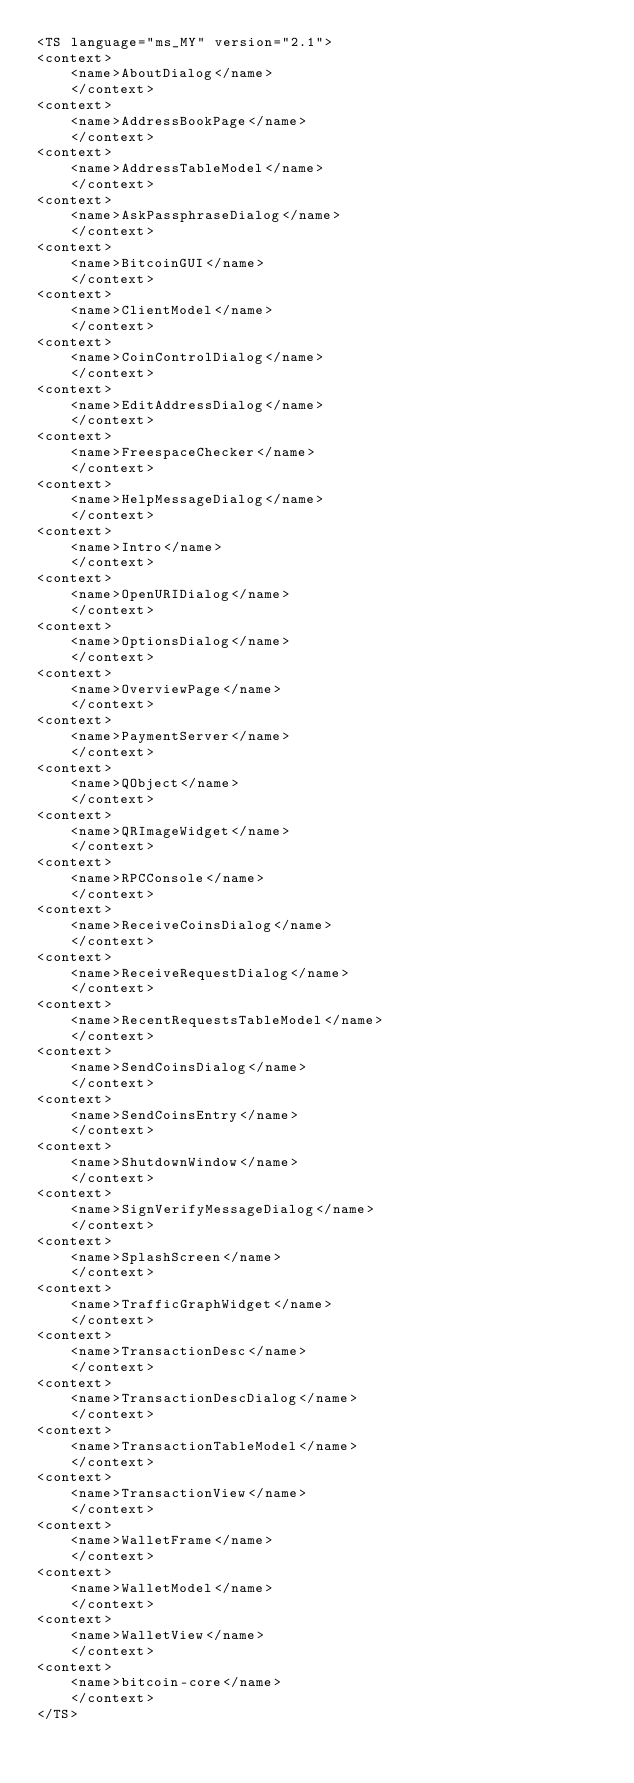Convert code to text. <code><loc_0><loc_0><loc_500><loc_500><_TypeScript_><TS language="ms_MY" version="2.1">
<context>
    <name>AboutDialog</name>
    </context>
<context>
    <name>AddressBookPage</name>
    </context>
<context>
    <name>AddressTableModel</name>
    </context>
<context>
    <name>AskPassphraseDialog</name>
    </context>
<context>
    <name>BitcoinGUI</name>
    </context>
<context>
    <name>ClientModel</name>
    </context>
<context>
    <name>CoinControlDialog</name>
    </context>
<context>
    <name>EditAddressDialog</name>
    </context>
<context>
    <name>FreespaceChecker</name>
    </context>
<context>
    <name>HelpMessageDialog</name>
    </context>
<context>
    <name>Intro</name>
    </context>
<context>
    <name>OpenURIDialog</name>
    </context>
<context>
    <name>OptionsDialog</name>
    </context>
<context>
    <name>OverviewPage</name>
    </context>
<context>
    <name>PaymentServer</name>
    </context>
<context>
    <name>QObject</name>
    </context>
<context>
    <name>QRImageWidget</name>
    </context>
<context>
    <name>RPCConsole</name>
    </context>
<context>
    <name>ReceiveCoinsDialog</name>
    </context>
<context>
    <name>ReceiveRequestDialog</name>
    </context>
<context>
    <name>RecentRequestsTableModel</name>
    </context>
<context>
    <name>SendCoinsDialog</name>
    </context>
<context>
    <name>SendCoinsEntry</name>
    </context>
<context>
    <name>ShutdownWindow</name>
    </context>
<context>
    <name>SignVerifyMessageDialog</name>
    </context>
<context>
    <name>SplashScreen</name>
    </context>
<context>
    <name>TrafficGraphWidget</name>
    </context>
<context>
    <name>TransactionDesc</name>
    </context>
<context>
    <name>TransactionDescDialog</name>
    </context>
<context>
    <name>TransactionTableModel</name>
    </context>
<context>
    <name>TransactionView</name>
    </context>
<context>
    <name>WalletFrame</name>
    </context>
<context>
    <name>WalletModel</name>
    </context>
<context>
    <name>WalletView</name>
    </context>
<context>
    <name>bitcoin-core</name>
    </context>
</TS></code> 